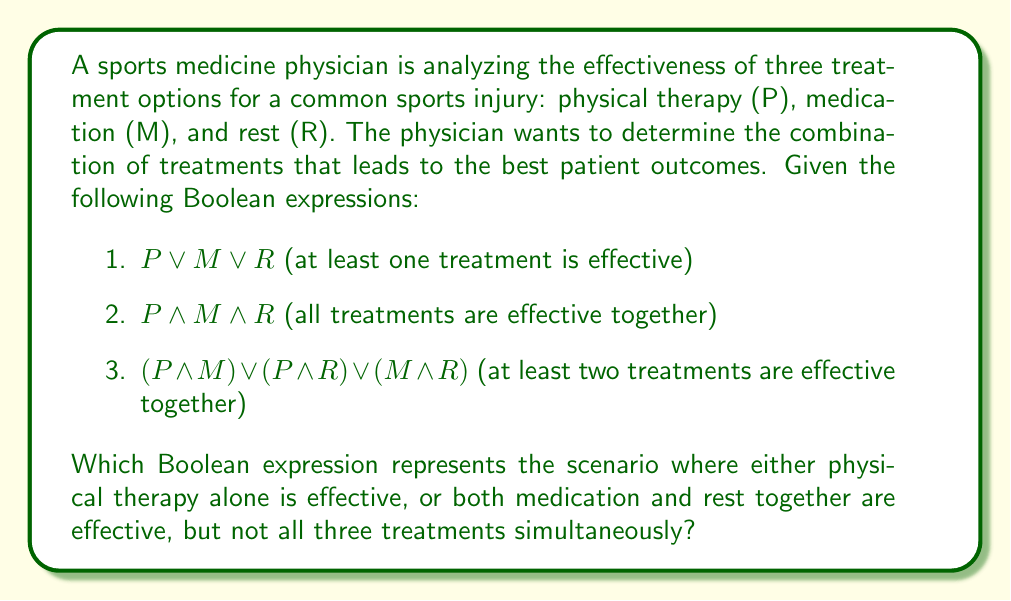Could you help me with this problem? Let's approach this step-by-step:

1. We need to represent "physical therapy alone is effective":
   This can be written as $P \land \lnot M \land \lnot R$

2. We also need to represent "both medication and rest together are effective":
   This can be written as $\lnot P \land M \land R$

3. We want either of these scenarios to be true, but not both (as that would imply all three are effective). We can use the XOR (exclusive OR) operator, symbolized by $\oplus$:

   $(P \land \lnot M \land \lnot R) \oplus (\lnot P \land M \land R)$

4. However, XOR is not typically considered a basic Boolean operator. We can express XOR using basic operators:

   $A \oplus B = (A \lor B) \land \lnot(A \land B)$

5. Applying this to our expression:

   $((P \land \lnot M \land \lnot R) \lor (\lnot P \land M \land R)) \land \lnot((P \land \lnot M \land \lnot R) \land (\lnot P \land M \land R))$

6. The second part of this expression $(\lnot((P \land \lnot M \land \lnot R) \land (\lnot P \land M \land R)))$ is always true because P cannot be both true and false simultaneously. Therefore, we can simplify our final expression to:

   $(P \land \lnot M \land \lnot R) \lor (\lnot P \land M \land R)$

This expression represents the scenario where either physical therapy alone is effective, or both medication and rest together are effective, but not all three treatments simultaneously.
Answer: $(P \land \lnot M \land \lnot R) \lor (\lnot P \land M \land R)$ 